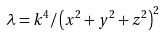Convert formula to latex. <formula><loc_0><loc_0><loc_500><loc_500>\lambda = k ^ { 4 } / \left ( x ^ { 2 } + y ^ { 2 } + z ^ { 2 } \right ) ^ { 2 }</formula> 